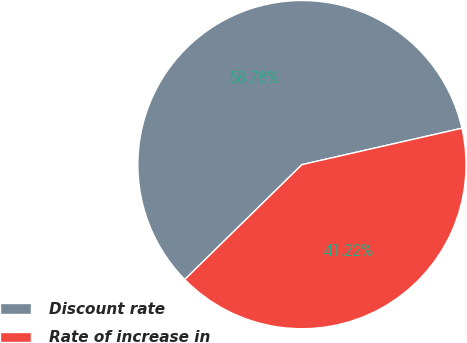Convert chart to OTSL. <chart><loc_0><loc_0><loc_500><loc_500><pie_chart><fcel>Discount rate<fcel>Rate of increase in<nl><fcel>58.78%<fcel>41.22%<nl></chart> 